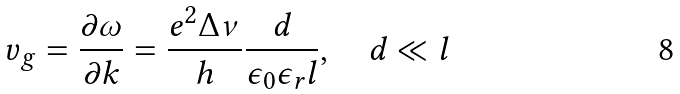<formula> <loc_0><loc_0><loc_500><loc_500>v _ { g } = \frac { \partial \omega } { \partial k } = \frac { e ^ { 2 } \Delta \nu } { h } \frac { d } { \epsilon _ { 0 } \epsilon _ { r } l } , \quad d \ll l</formula> 